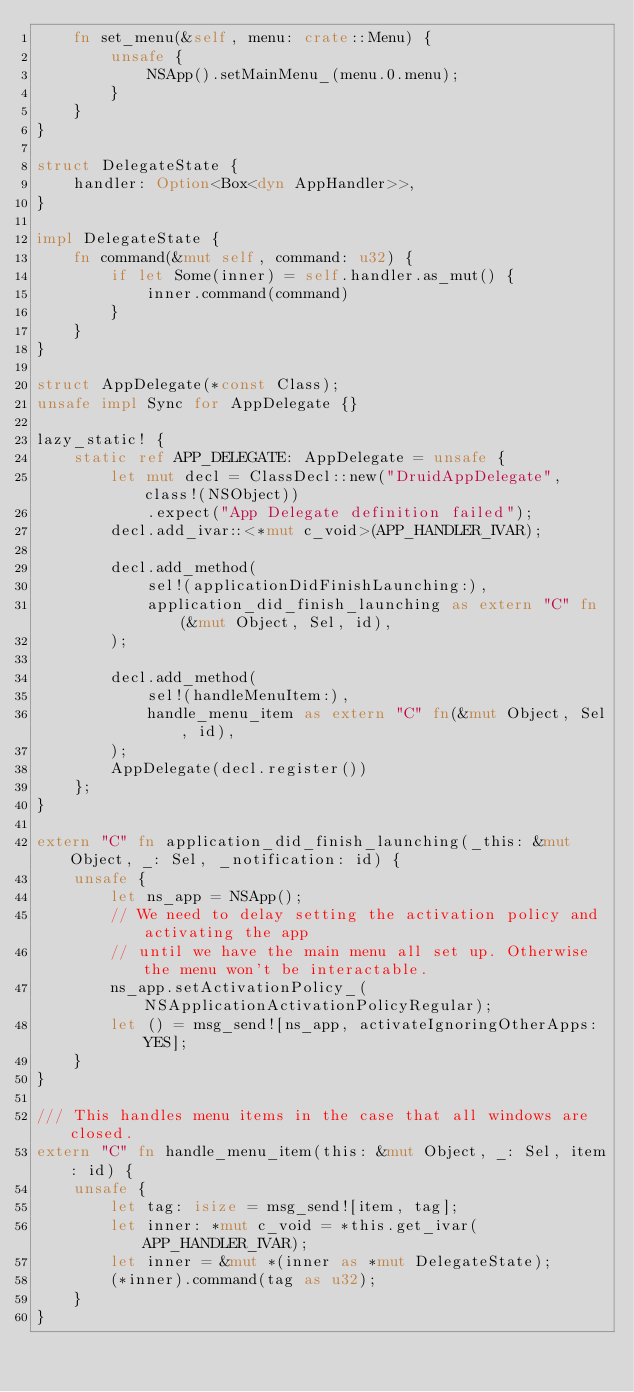Convert code to text. <code><loc_0><loc_0><loc_500><loc_500><_Rust_>    fn set_menu(&self, menu: crate::Menu) {
        unsafe {
            NSApp().setMainMenu_(menu.0.menu);
        }
    }
}

struct DelegateState {
    handler: Option<Box<dyn AppHandler>>,
}

impl DelegateState {
    fn command(&mut self, command: u32) {
        if let Some(inner) = self.handler.as_mut() {
            inner.command(command)
        }
    }
}

struct AppDelegate(*const Class);
unsafe impl Sync for AppDelegate {}

lazy_static! {
    static ref APP_DELEGATE: AppDelegate = unsafe {
        let mut decl = ClassDecl::new("DruidAppDelegate", class!(NSObject))
            .expect("App Delegate definition failed");
        decl.add_ivar::<*mut c_void>(APP_HANDLER_IVAR);

        decl.add_method(
            sel!(applicationDidFinishLaunching:),
            application_did_finish_launching as extern "C" fn(&mut Object, Sel, id),
        );

        decl.add_method(
            sel!(handleMenuItem:),
            handle_menu_item as extern "C" fn(&mut Object, Sel, id),
        );
        AppDelegate(decl.register())
    };
}

extern "C" fn application_did_finish_launching(_this: &mut Object, _: Sel, _notification: id) {
    unsafe {
        let ns_app = NSApp();
        // We need to delay setting the activation policy and activating the app
        // until we have the main menu all set up. Otherwise the menu won't be interactable.
        ns_app.setActivationPolicy_(NSApplicationActivationPolicyRegular);
        let () = msg_send![ns_app, activateIgnoringOtherApps: YES];
    }
}

/// This handles menu items in the case that all windows are closed.
extern "C" fn handle_menu_item(this: &mut Object, _: Sel, item: id) {
    unsafe {
        let tag: isize = msg_send![item, tag];
        let inner: *mut c_void = *this.get_ivar(APP_HANDLER_IVAR);
        let inner = &mut *(inner as *mut DelegateState);
        (*inner).command(tag as u32);
    }
}
</code> 